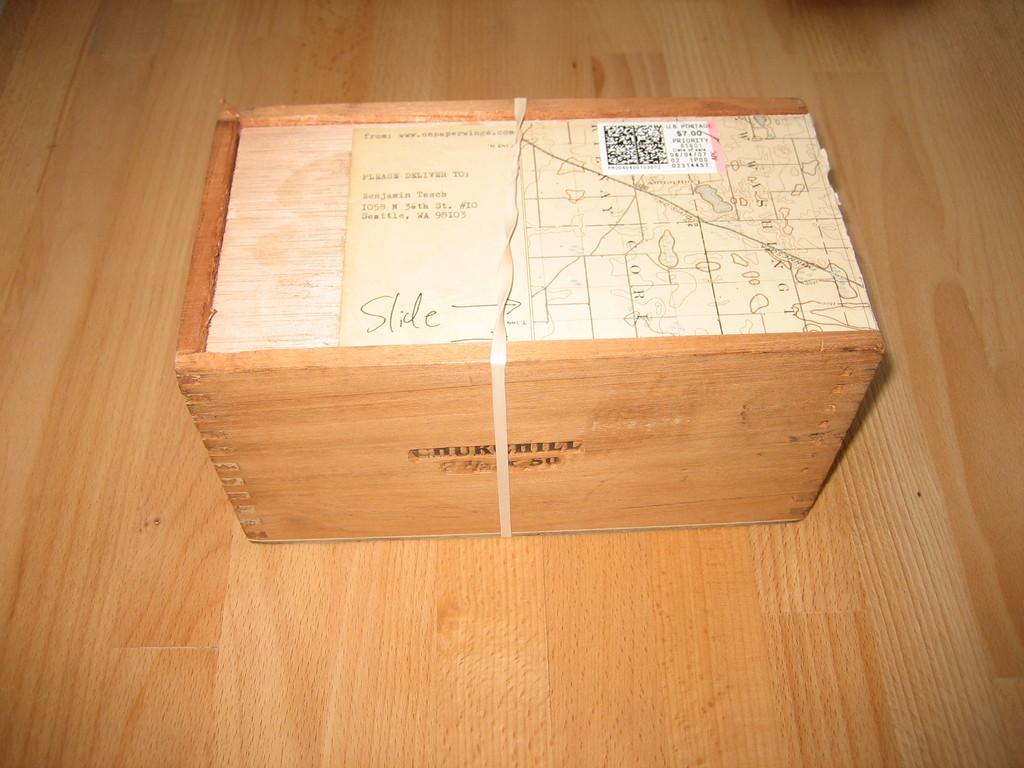Provide a one-sentence caption for the provided image. A wooden box that says slide on the top. 